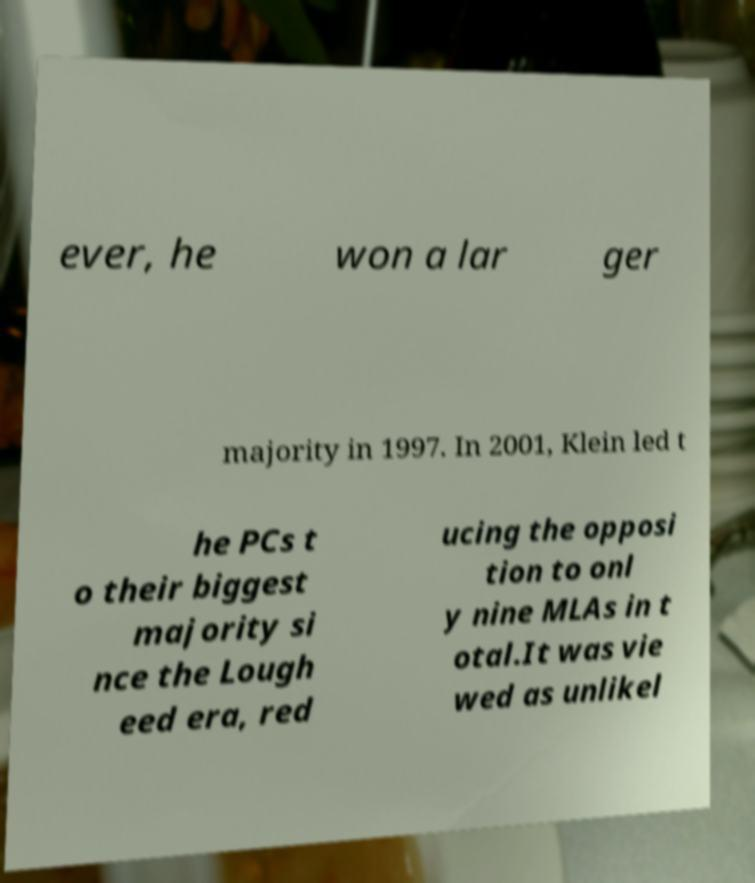What messages or text are displayed in this image? I need them in a readable, typed format. ever, he won a lar ger majority in 1997. In 2001, Klein led t he PCs t o their biggest majority si nce the Lough eed era, red ucing the opposi tion to onl y nine MLAs in t otal.It was vie wed as unlikel 